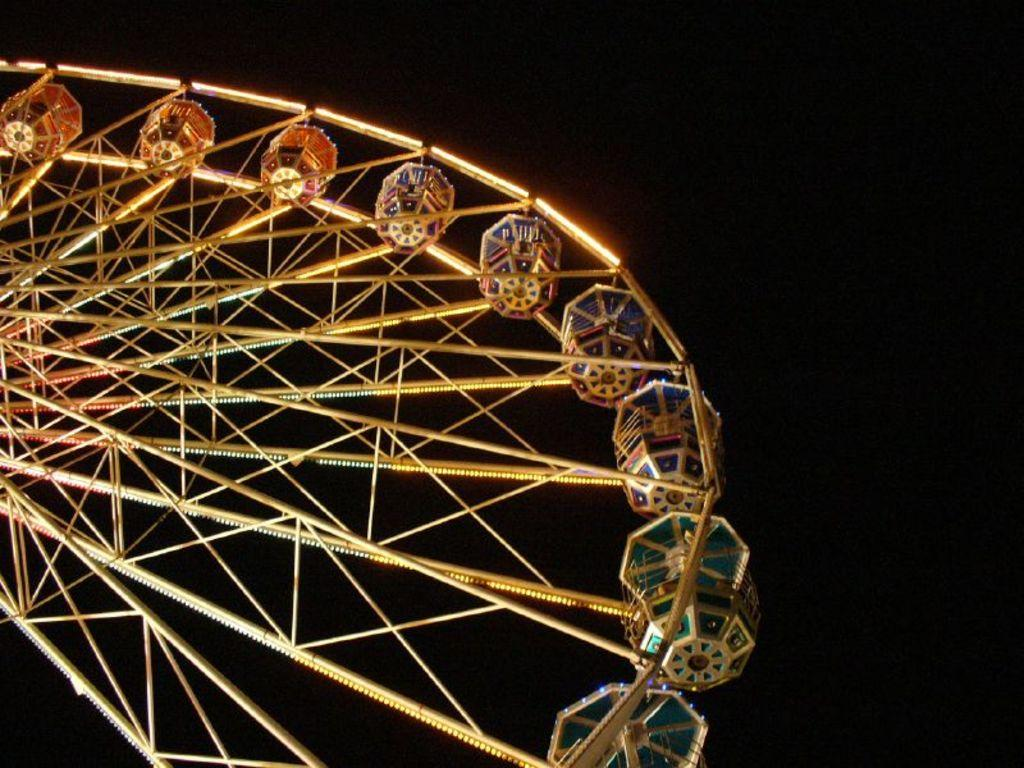What type of wheel is shown in the image? There is a joint wheel in the image. Can you describe the background of the image? The background of the image is dark. What role does the father play in the image? There is no reference to a father or any people in the image, so it's not possible to determine what role a father might play. 